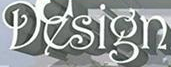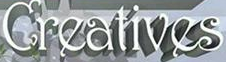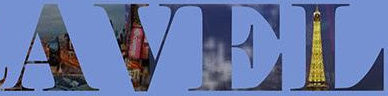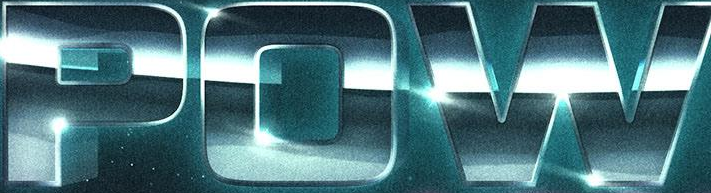What words can you see in these images in sequence, separated by a semicolon? Design; Creatives; AVEL; POW 